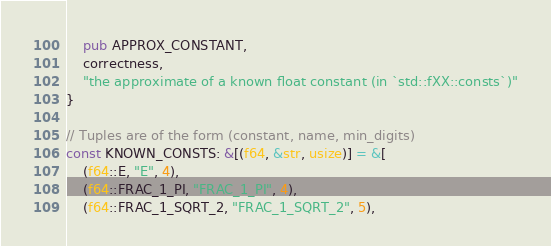<code> <loc_0><loc_0><loc_500><loc_500><_Rust_>    pub APPROX_CONSTANT,
    correctness,
    "the approximate of a known float constant (in `std::fXX::consts`)"
}

// Tuples are of the form (constant, name, min_digits)
const KNOWN_CONSTS: &[(f64, &str, usize)] = &[
    (f64::E, "E", 4),
    (f64::FRAC_1_PI, "FRAC_1_PI", 4),
    (f64::FRAC_1_SQRT_2, "FRAC_1_SQRT_2", 5),</code> 